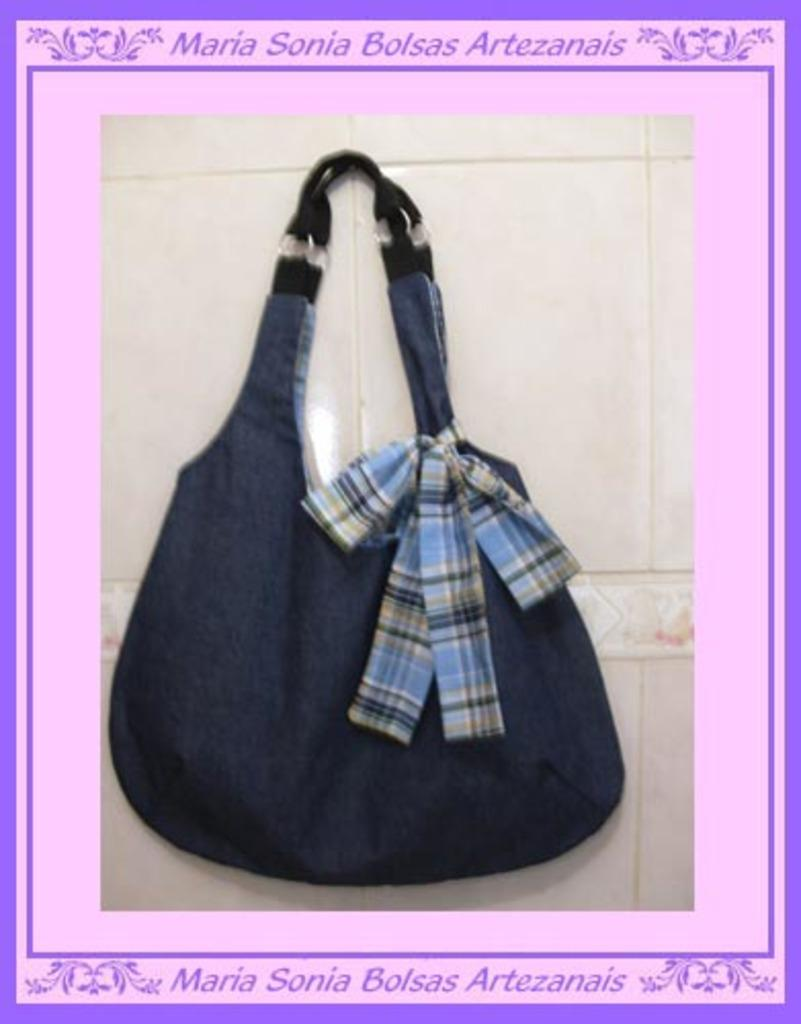What is the main subject of the image? There is a handbag in the center of the image. Can you describe the handbag in more detail? Unfortunately, the image only shows the handbag in the center, so we cannot provide more details about its appearance or contents. Is there anything else visible in the image besides the handbag? No, the image only shows the handbag in the center, with no other objects or background visible. How many holes are visible in the handbag in the image? There are no holes visible in the handbag in the image, as the image only shows the handbag in the center with no other details provided. 